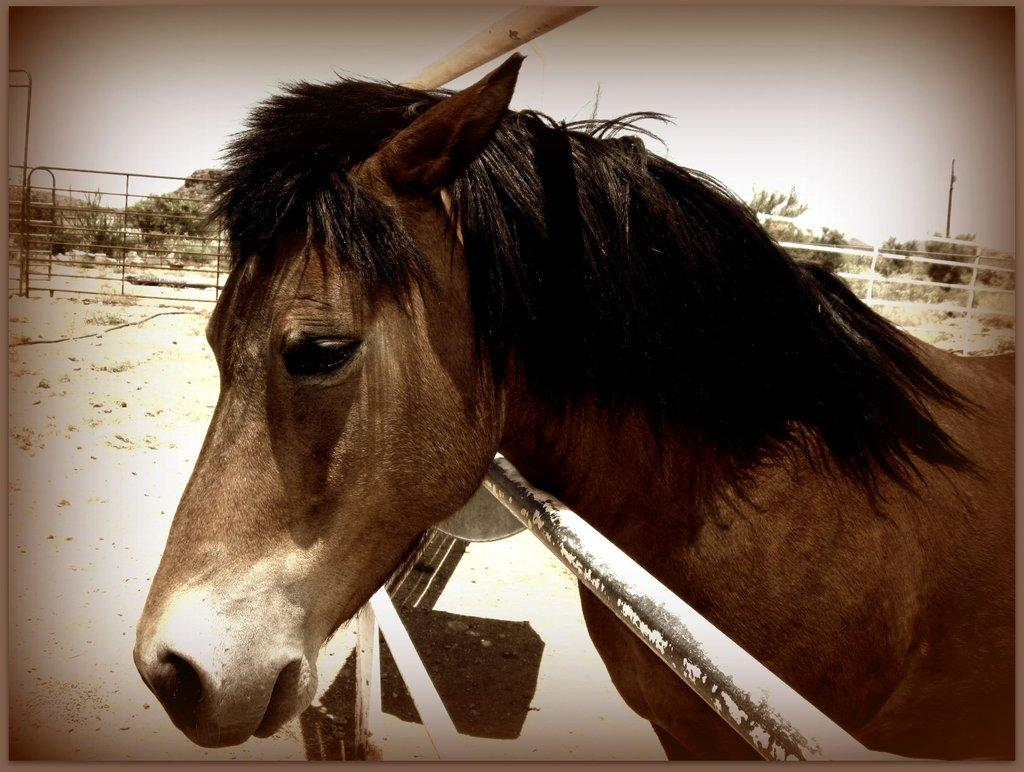What animal is the main subject of the image? There is a horse in the image. What is the white pole used for in the image? The white pole is below and above the horse's neck, which suggests it might suggest it might be a bridle or a halter. What can be seen in the background of the image? There is a fence and trees present in the background of the image. What type of wax is being used to create the horse's feet in the image? There is no wax present in the image, and the horse's feet are not being created or sculpted. 